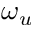<formula> <loc_0><loc_0><loc_500><loc_500>\omega _ { u }</formula> 